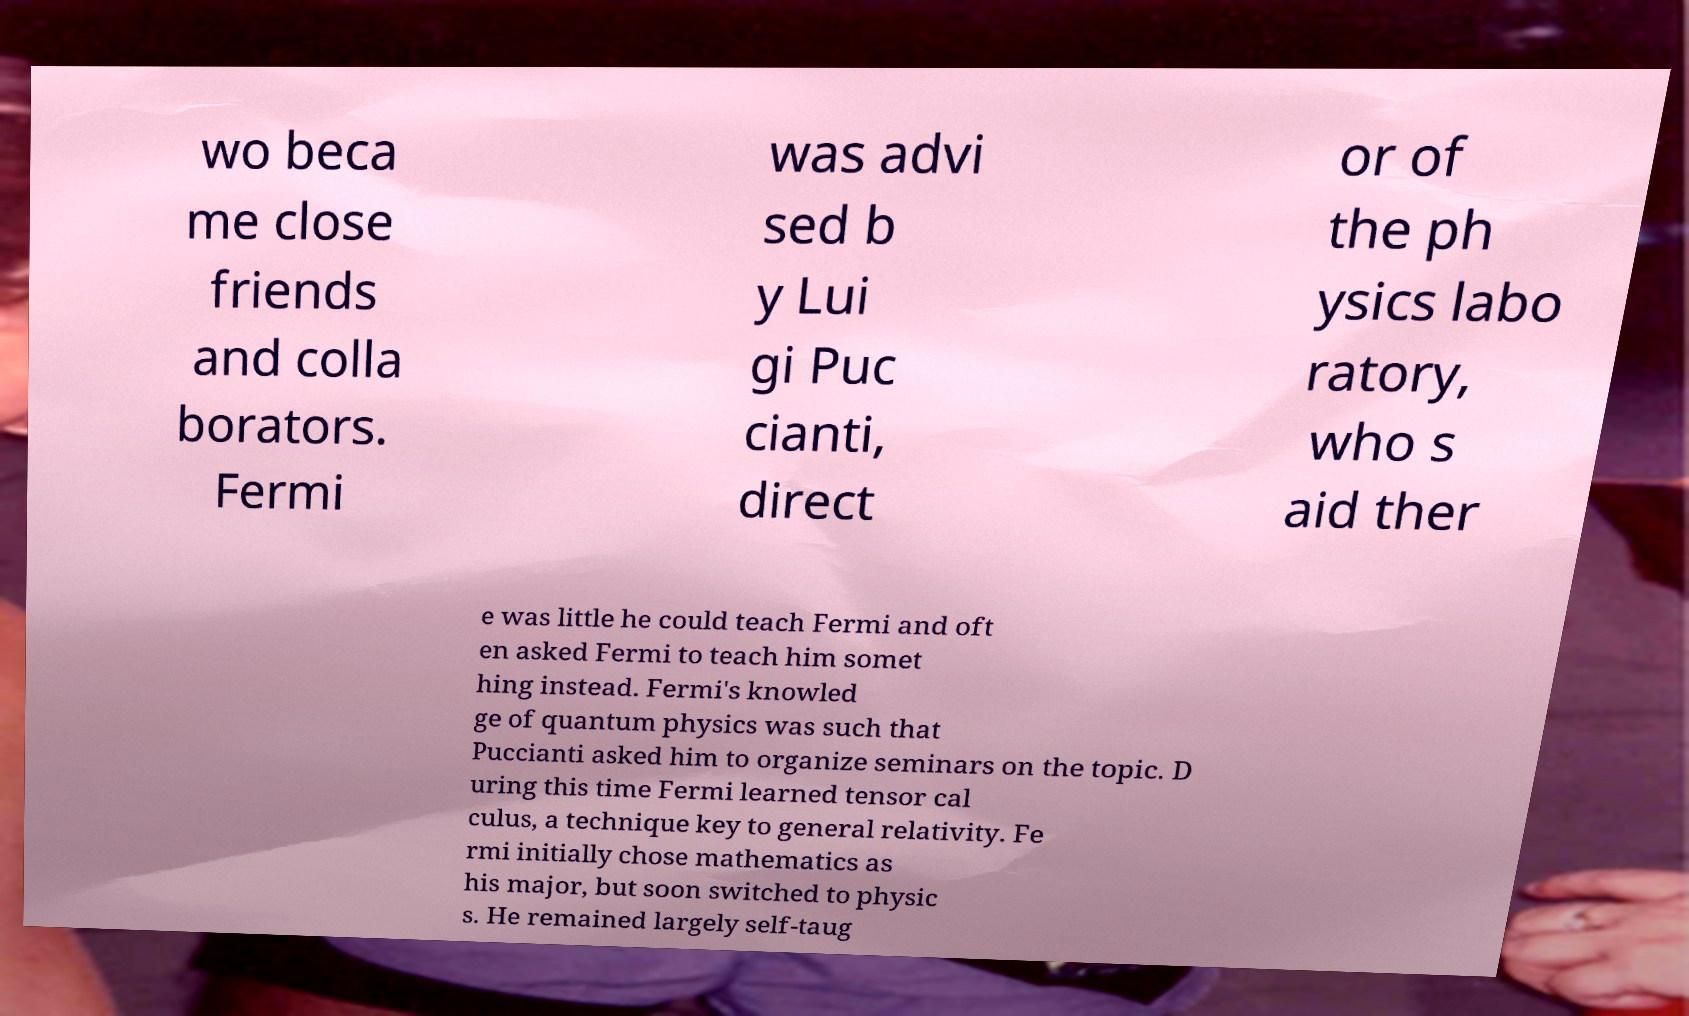Could you extract and type out the text from this image? wo beca me close friends and colla borators. Fermi was advi sed b y Lui gi Puc cianti, direct or of the ph ysics labo ratory, who s aid ther e was little he could teach Fermi and oft en asked Fermi to teach him somet hing instead. Fermi's knowled ge of quantum physics was such that Puccianti asked him to organize seminars on the topic. D uring this time Fermi learned tensor cal culus, a technique key to general relativity. Fe rmi initially chose mathematics as his major, but soon switched to physic s. He remained largely self-taug 